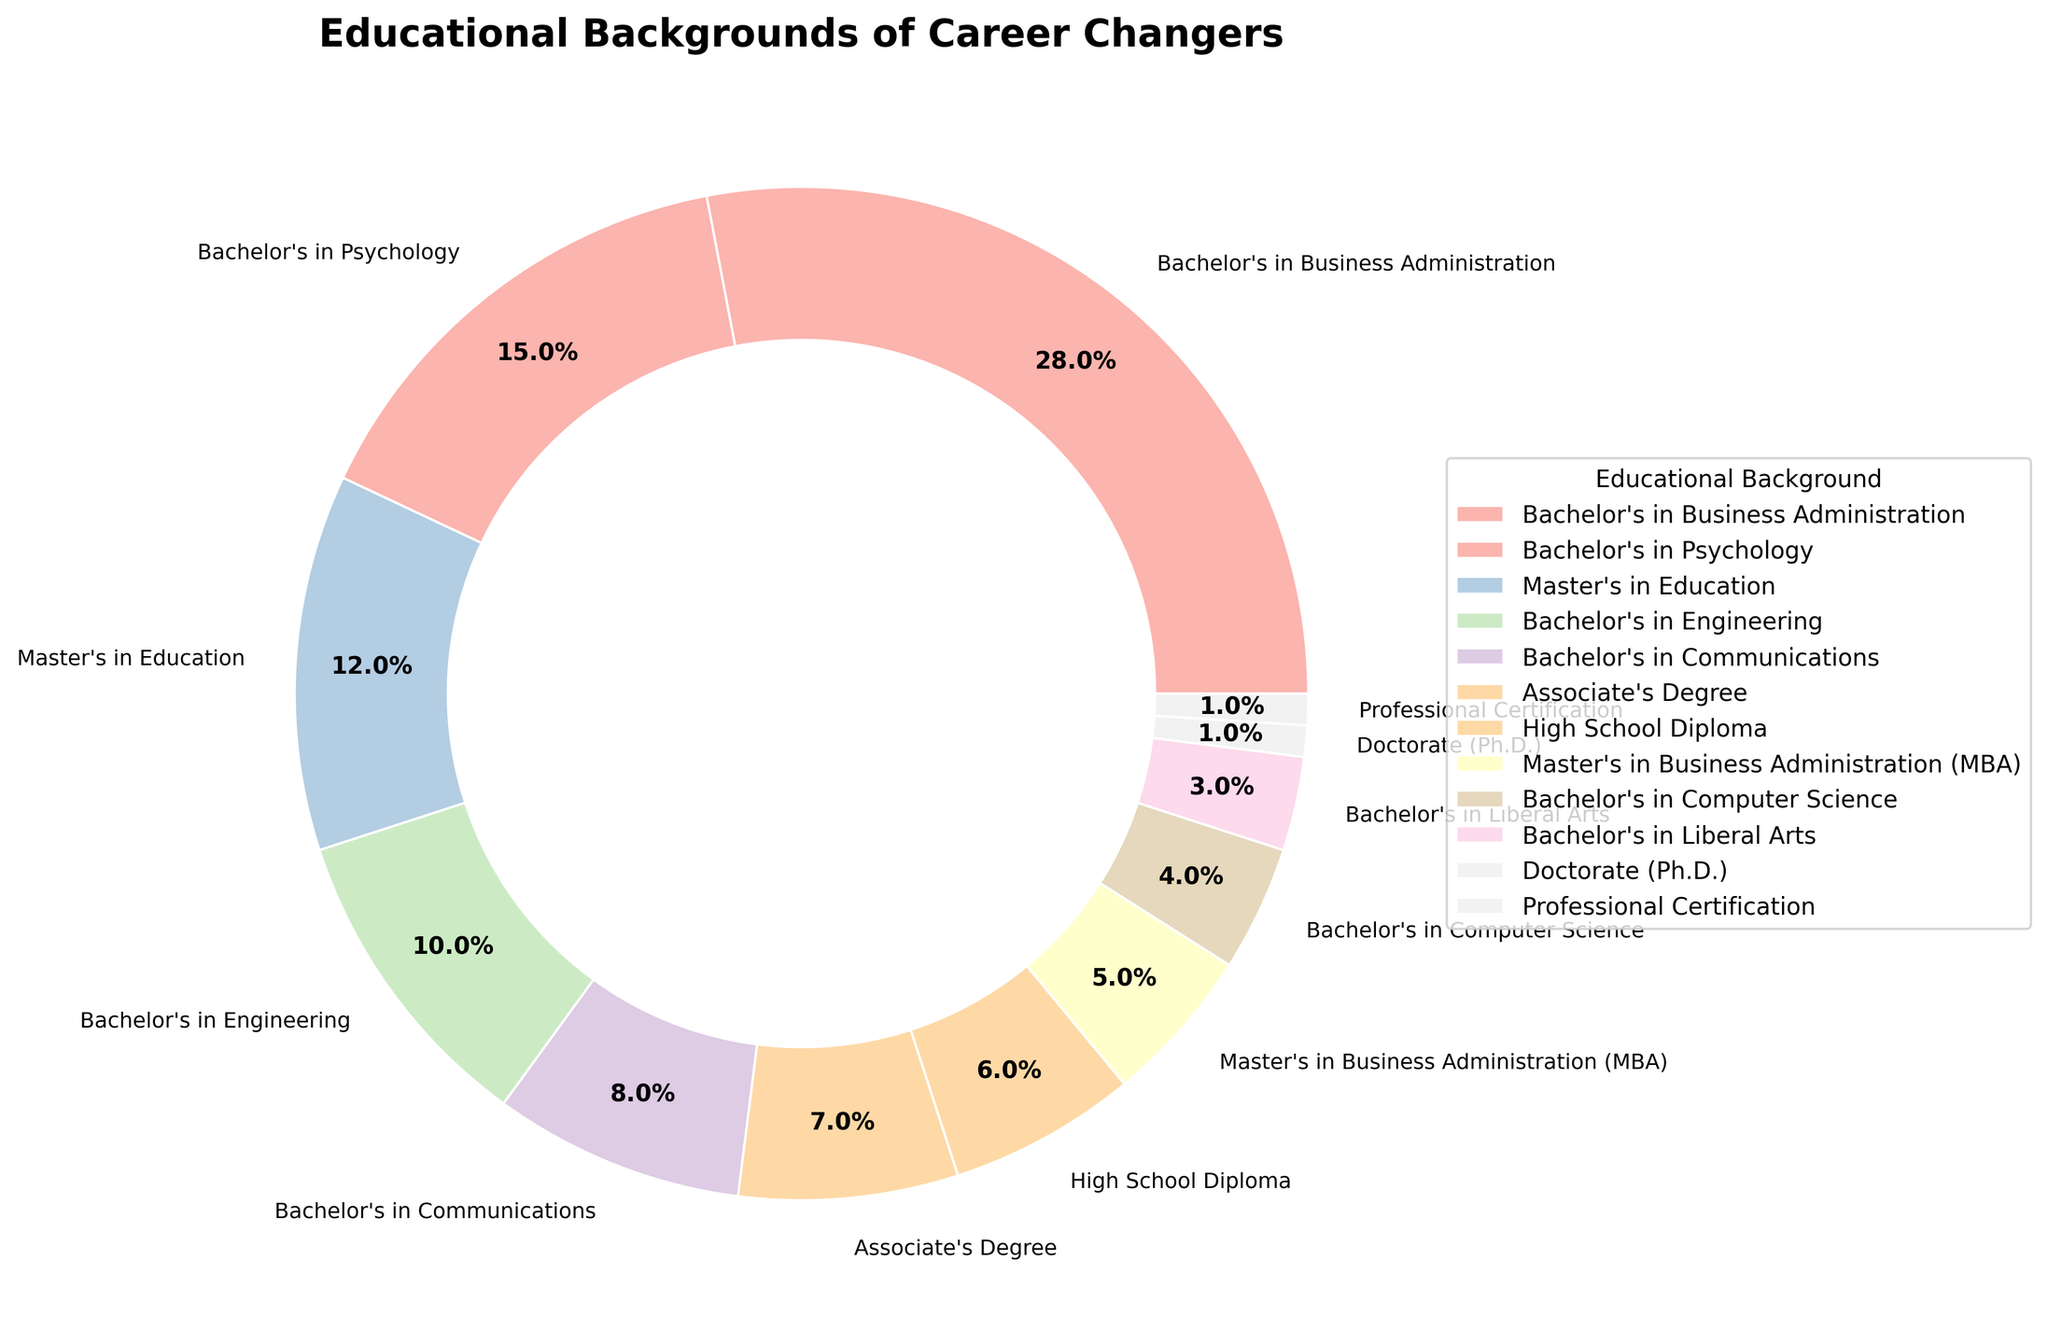Which educational background has the highest percentage among career changers? The largest sector in the pie chart represents the educational background with the highest percentage. Visually, this is identified by the largest wedge.
Answer: Bachelor's in Business Administration What is the combined percentage of career changers with a Bachelor's in Engineering and Bachelor's in Computer Science? Sum the percentages associated with each educational background: Bachelor's in Engineering (10%) + Bachelor's in Computer Science (4%) = 14%
Answer: 14% Which two educational backgrounds have the smallest representation among career changers, and what is their combined percentage? Identify the two smallest sectors in the pie chart, which are for Doctorate (Ph.D.) and Professional Certification. Sum their percentages: Doctorate (Ph.D.) (1%) + Professional Certification (1%) = 2%
Answer: Doctorate (Ph.D.) and Professional Certification; 2% Are there more career changers with a Master’s in Education or Bachelor’s in Psychology? Compare the percentages: Master’s in Education (12%) versus Bachelor’s in Psychology (15%).
Answer: Bachelor's in Psychology What is the difference in the percentage between career changers with a Master’s in Business Administration (MBA) and those with an Associate’s Degree? Subtract the percentage of Master’s in Business Administration (MBA) (5%) from the percentage of Associate’s Degree (7%): 7% - 5% = 2%
Answer: 2% How does the percentage of career changers with only a High School Diploma compare to those with a Bachelor's in Liberal Arts? Compare the slices: High School Diploma (6%) versus Bachelor's in Liberal Arts (3%).
Answer: Higher Which educational background with a percentage lower than 10% still holds the highest percentage among career changers? Look for the highest percentage among those less than 10%: Bachelor's in Communications (8%).
Answer: Bachelor's in Communications What is the aggregated percentage of career changers with a Bachelor's degree in different fields (excluding Master’s, Associate’s, and other degrees)? Sum all the percentages of various Bachelor’s degrees: Business Administration (28%) + Psychology (15%) + Engineering (10%) + Communications (8%) + Computer Science (4%) + Liberal Arts (3%) = 68%
Answer: 68% Identify the educational background with a wedge that is roughly half the size of the Bachelor's in Business Administration. The Bachelor's in Business Administration is at 28%, so half would be around 14%. The closest segment is Bachelor's in Psychology (15%).
Answer: Bachelor's in Psychology 